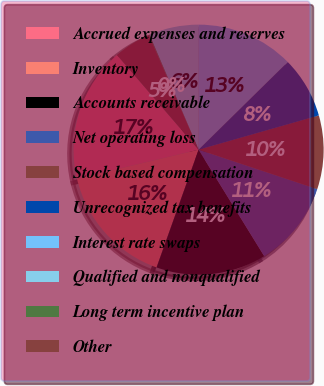Convert chart. <chart><loc_0><loc_0><loc_500><loc_500><pie_chart><fcel>Accrued expenses and reserves<fcel>Inventory<fcel>Accounts receivable<fcel>Net operating loss<fcel>Stock based compensation<fcel>Unrecognized tax benefits<fcel>Interest rate swaps<fcel>Qualified and nonqualified<fcel>Long term incentive plan<fcel>Other<nl><fcel>17.4%<fcel>15.82%<fcel>14.25%<fcel>11.1%<fcel>9.53%<fcel>7.95%<fcel>12.68%<fcel>6.38%<fcel>0.09%<fcel>4.81%<nl></chart> 